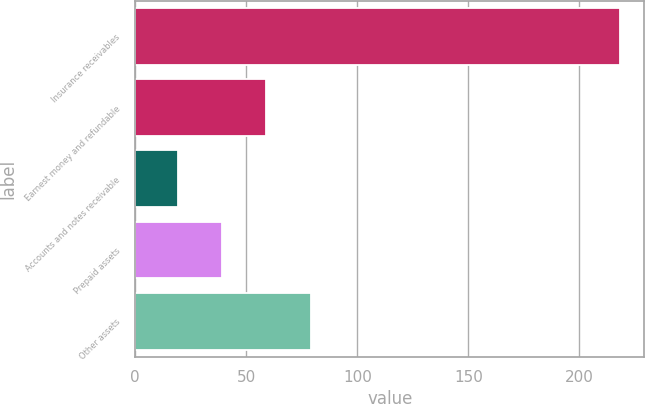<chart> <loc_0><loc_0><loc_500><loc_500><bar_chart><fcel>Insurance receivables<fcel>Earnest money and refundable<fcel>Accounts and notes receivable<fcel>Prepaid assets<fcel>Other assets<nl><fcel>218.3<fcel>59.1<fcel>19.1<fcel>39.02<fcel>79.02<nl></chart> 